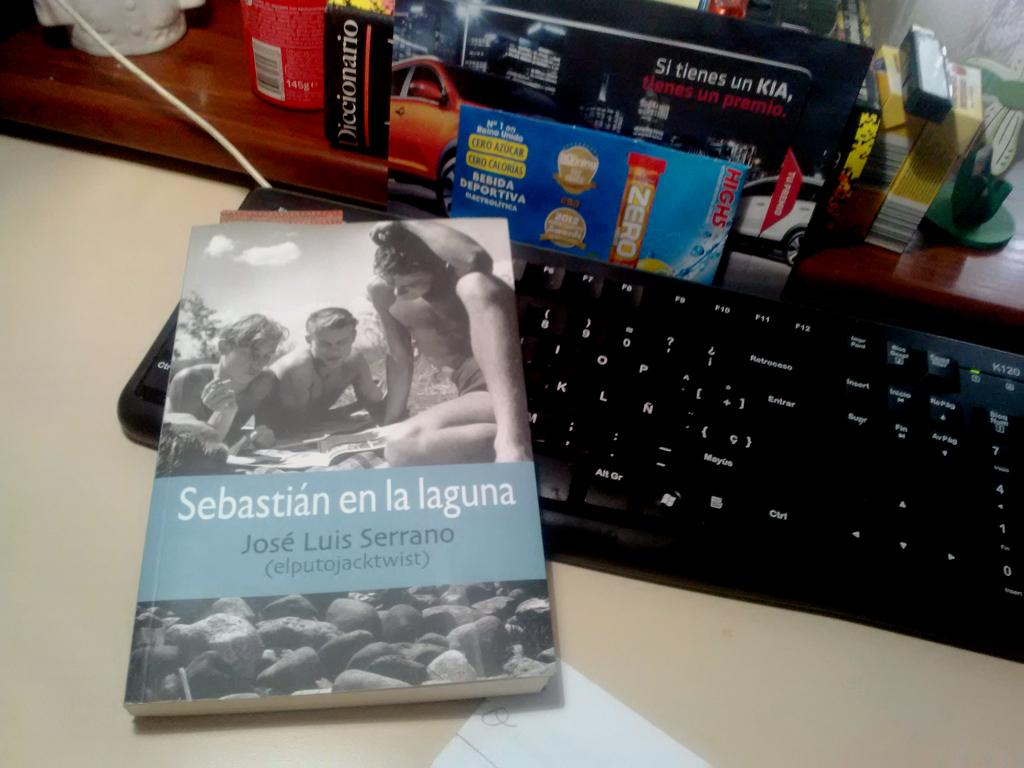What is one of the objects visible in the image? There is a book in the image. What other object can be seen in the image? There is a keyboard in the image. What is the third object visible in the image? There is a paper in the image. What type of surface is visible in the image? The wooden surface is visible in the image. Can you describe the background of the image? There are a few objects visible in the background of the image. Can you describe the wave that is visible in the image? There is no wave present in the image; it features a book, keyboard, paper, and wooden surface. What type of volleyball game is taking place in the background of the image? There is no volleyball game present in the image; it only shows a few objects in the background. 